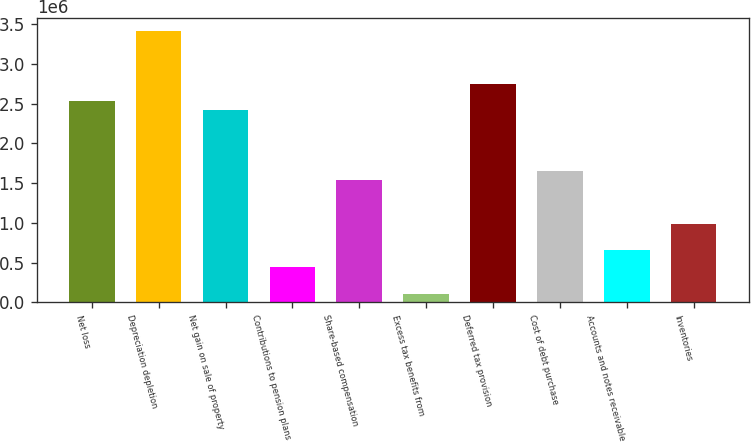Convert chart to OTSL. <chart><loc_0><loc_0><loc_500><loc_500><bar_chart><fcel>Net loss<fcel>Depreciation depletion<fcel>Net gain on sale of property<fcel>Contributions to pension plans<fcel>Share-based compensation<fcel>Excess tax benefits from<fcel>Deferred tax provision<fcel>Cost of debt purchase<fcel>Accounts and notes receivable<fcel>Inventories<nl><fcel>2.52999e+06<fcel>3.40999e+06<fcel>2.41999e+06<fcel>440003<fcel>1.54e+06<fcel>110004<fcel>2.74999e+06<fcel>1.65e+06<fcel>660002<fcel>990000<nl></chart> 